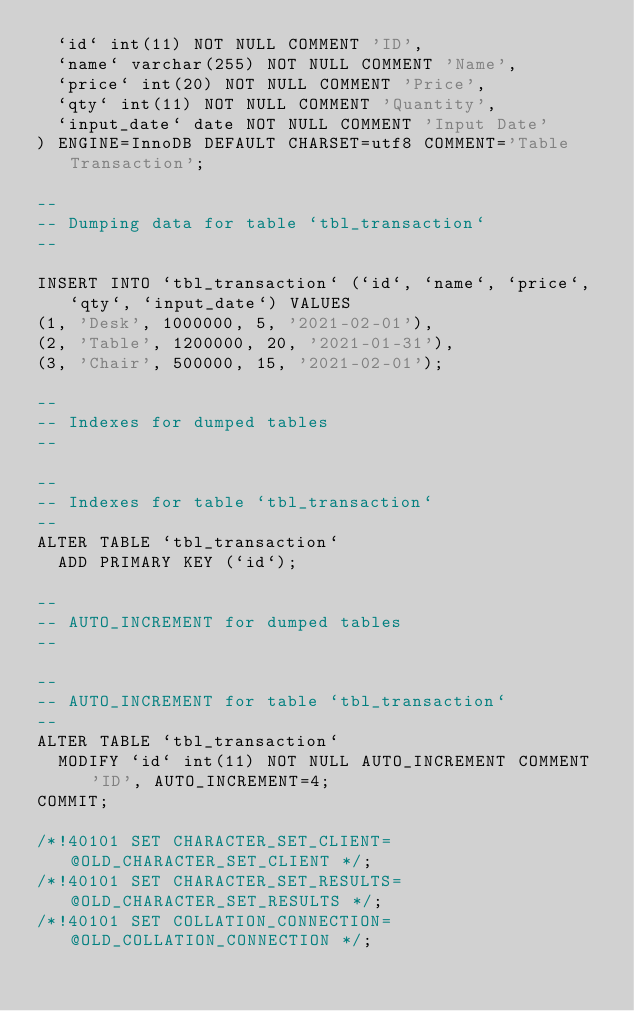Convert code to text. <code><loc_0><loc_0><loc_500><loc_500><_SQL_>  `id` int(11) NOT NULL COMMENT 'ID',
  `name` varchar(255) NOT NULL COMMENT 'Name',
  `price` int(20) NOT NULL COMMENT 'Price',
  `qty` int(11) NOT NULL COMMENT 'Quantity',
  `input_date` date NOT NULL COMMENT 'Input Date'
) ENGINE=InnoDB DEFAULT CHARSET=utf8 COMMENT='Table Transaction';

--
-- Dumping data for table `tbl_transaction`
--

INSERT INTO `tbl_transaction` (`id`, `name`, `price`, `qty`, `input_date`) VALUES
(1, 'Desk', 1000000, 5, '2021-02-01'),
(2, 'Table', 1200000, 20, '2021-01-31'),
(3, 'Chair', 500000, 15, '2021-02-01');

--
-- Indexes for dumped tables
--

--
-- Indexes for table `tbl_transaction`
--
ALTER TABLE `tbl_transaction`
  ADD PRIMARY KEY (`id`);

--
-- AUTO_INCREMENT for dumped tables
--

--
-- AUTO_INCREMENT for table `tbl_transaction`
--
ALTER TABLE `tbl_transaction`
  MODIFY `id` int(11) NOT NULL AUTO_INCREMENT COMMENT 'ID', AUTO_INCREMENT=4;
COMMIT;

/*!40101 SET CHARACTER_SET_CLIENT=@OLD_CHARACTER_SET_CLIENT */;
/*!40101 SET CHARACTER_SET_RESULTS=@OLD_CHARACTER_SET_RESULTS */;
/*!40101 SET COLLATION_CONNECTION=@OLD_COLLATION_CONNECTION */;
</code> 